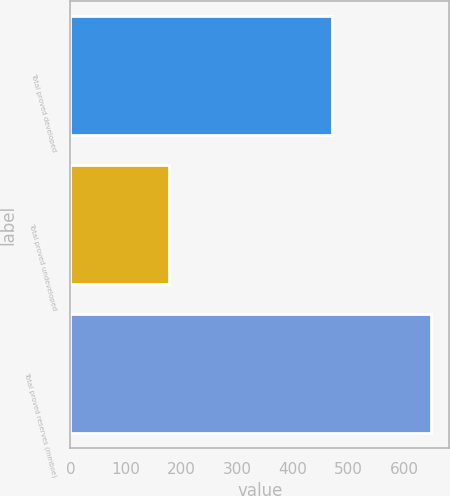Convert chart. <chart><loc_0><loc_0><loc_500><loc_500><bar_chart><fcel>Total proved developed<fcel>Total proved undeveloped<fcel>Total proved reserves (mmboe)<nl><fcel>471<fcel>178<fcel>649<nl></chart> 